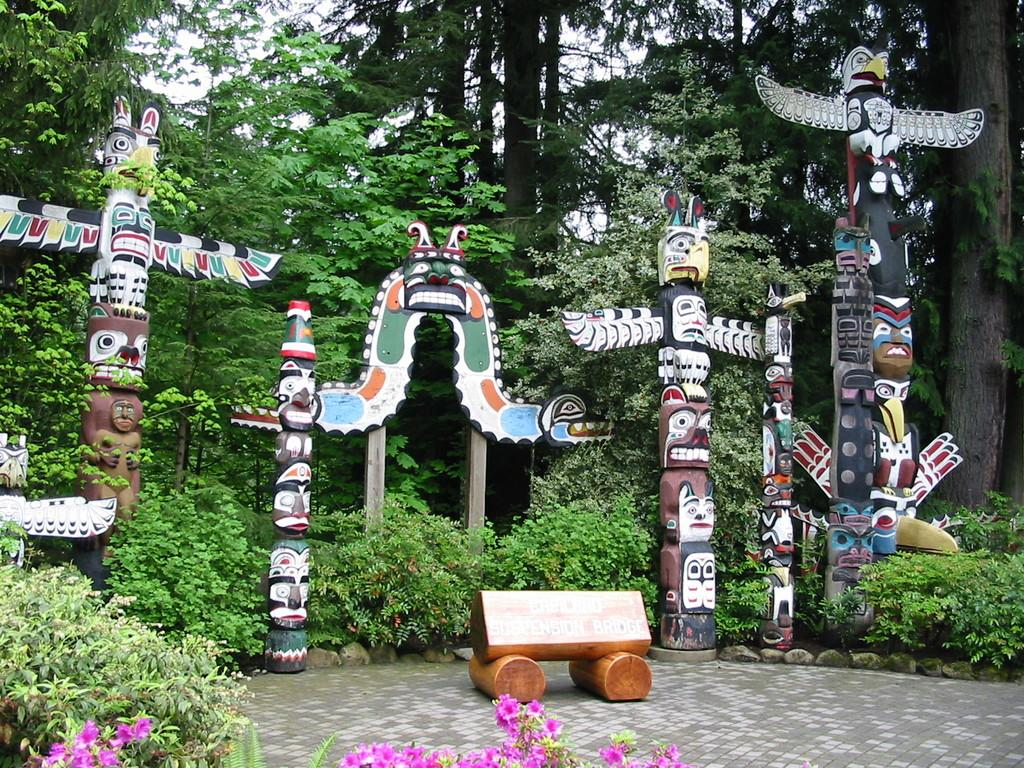What type of vegetation can be seen in the image? There are trees, plants, and flowers in the image. What kind of artifacts are present in the image? There are wooden carvings and a painting on wood in the image. What material are the barks made of? The wooden barks are made of wood. Are there any words or phrases on the wooden barks? Yes, there is text on the wooden barks. What is the grade of the wooden barks in the image? There is no grade mentioned for the wooden barks in the image. How does the trail look like in the image? There is no trail present in the image. 